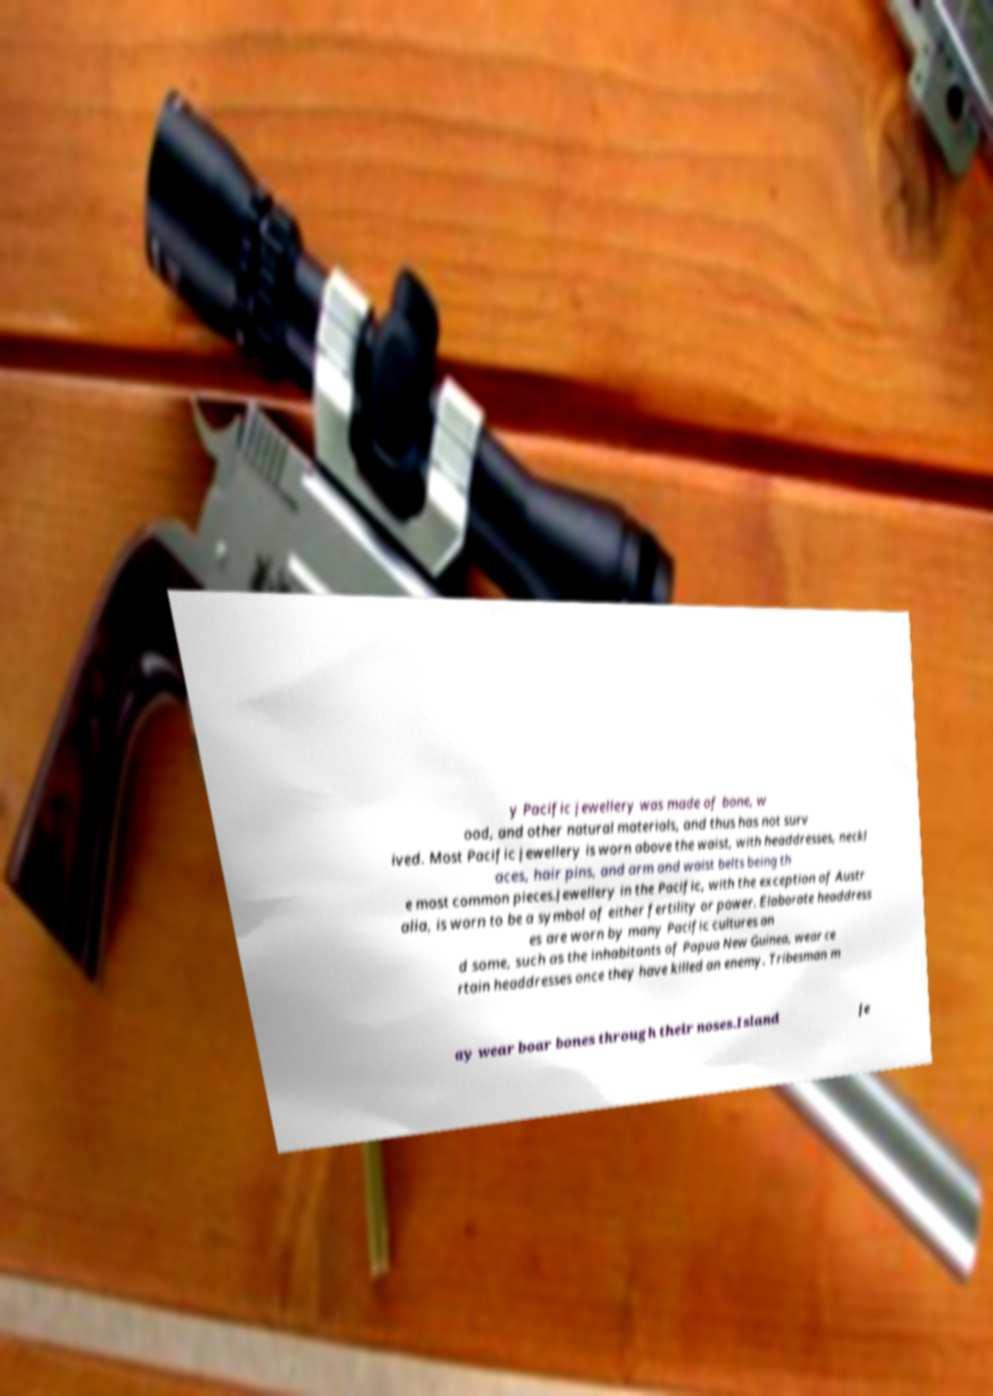Could you extract and type out the text from this image? y Pacific jewellery was made of bone, w ood, and other natural materials, and thus has not surv ived. Most Pacific jewellery is worn above the waist, with headdresses, neckl aces, hair pins, and arm and waist belts being th e most common pieces.Jewellery in the Pacific, with the exception of Austr alia, is worn to be a symbol of either fertility or power. Elaborate headdress es are worn by many Pacific cultures an d some, such as the inhabitants of Papua New Guinea, wear ce rtain headdresses once they have killed an enemy. Tribesman m ay wear boar bones through their noses.Island je 